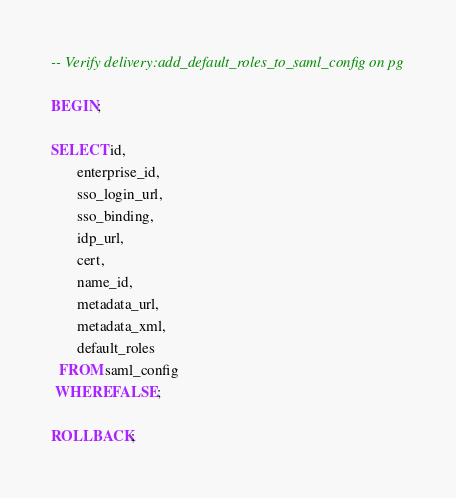<code> <loc_0><loc_0><loc_500><loc_500><_SQL_>-- Verify delivery:add_default_roles_to_saml_config on pg

BEGIN;

SELECT id,
       enterprise_id,
       sso_login_url,
       sso_binding,
       idp_url,
       cert,
       name_id,
       metadata_url,
       metadata_xml,
       default_roles
  FROM saml_config
 WHERE FALSE;

ROLLBACK;
</code> 